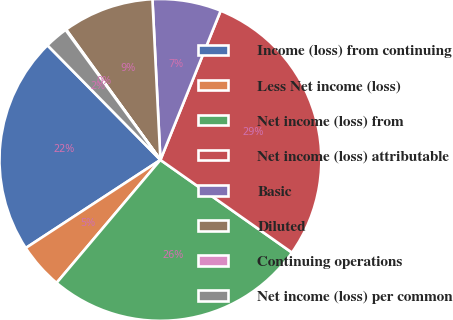Convert chart to OTSL. <chart><loc_0><loc_0><loc_500><loc_500><pie_chart><fcel>Income (loss) from continuing<fcel>Less Net income (loss)<fcel>Net income (loss) from<fcel>Net income (loss) attributable<fcel>Basic<fcel>Diluted<fcel>Continuing operations<fcel>Net income (loss) per common<nl><fcel>21.84%<fcel>4.62%<fcel>26.39%<fcel>28.66%<fcel>6.9%<fcel>9.17%<fcel>0.07%<fcel>2.35%<nl></chart> 